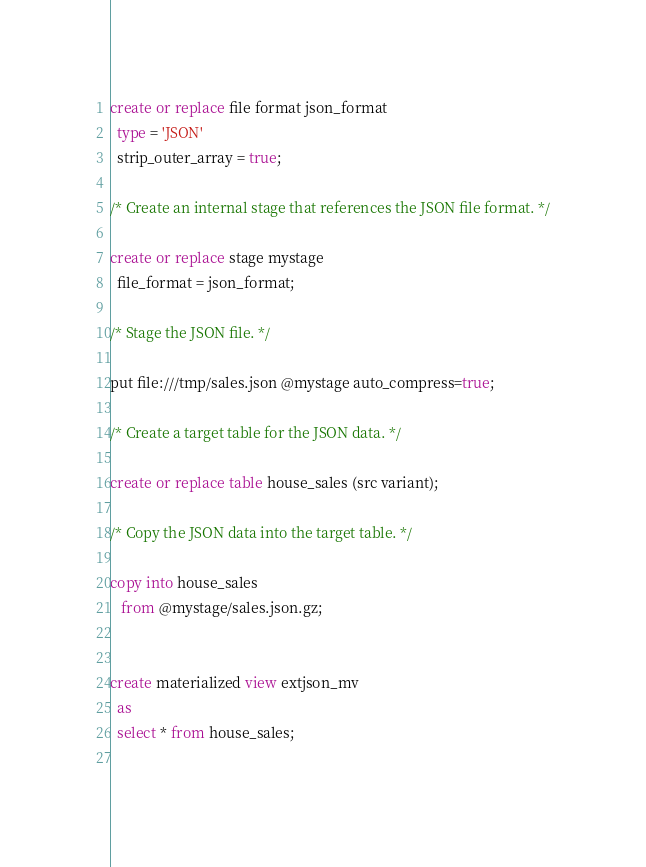<code> <loc_0><loc_0><loc_500><loc_500><_SQL_>create or replace file format json_format
  type = 'JSON'
  strip_outer_array = true;

/* Create an internal stage that references the JSON file format. */

create or replace stage mystage
  file_format = json_format;

/* Stage the JSON file. */

put file:///tmp/sales.json @mystage auto_compress=true;

/* Create a target table for the JSON data. */

create or replace table house_sales (src variant);

/* Copy the JSON data into the target table. */

copy into house_sales
   from @mystage/sales.json.gz;


create materialized view extjson_mv
  as
  select * from house_sales;  
  </code> 